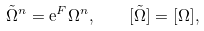<formula> <loc_0><loc_0><loc_500><loc_500>\tilde { \Omega } ^ { n } = \mathrm e ^ { F } \Omega ^ { n } , \quad [ \tilde { \Omega } ] = [ \Omega ] ,</formula> 